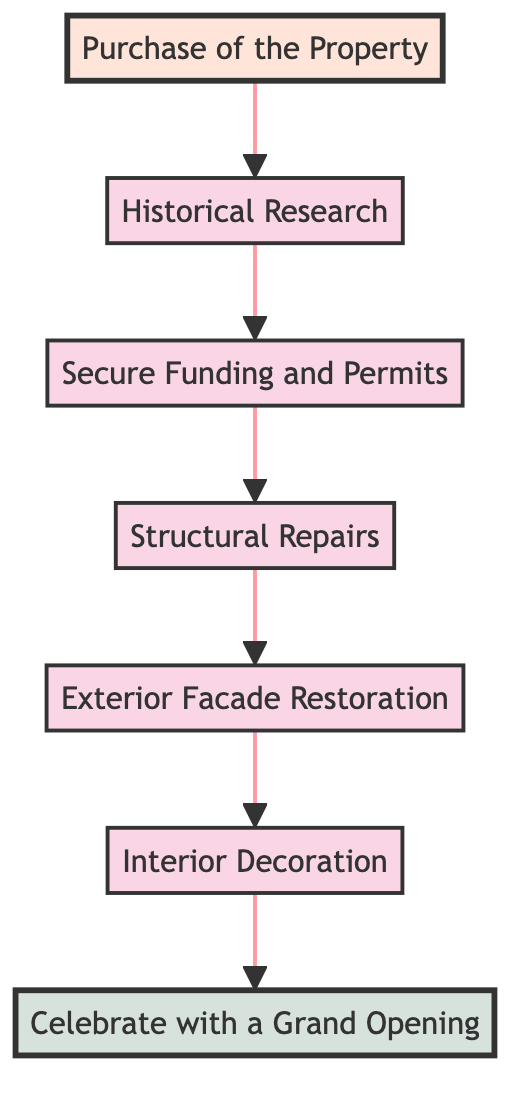What is the first step in the restoration process? The first step in the restoration process, as indicated in the diagram, is "Purchase of the Property," which is the starting point before any other steps can occur.
Answer: Purchase of the Property How many steps are there in total in the restoration process? In the diagram, there are a total of seven steps included, starting from "Purchase of the Property" and ending with "Celebrate with a Grand Opening."
Answer: 7 What comes after "Historical Research"? Following "Historical Research," the next step is "Secure Funding and Permits," which indicates the sequential process of obtaining necessary permissions and funding.
Answer: Secure Funding and Permits Which step directly precedes the "Celebrate with a Grand Opening"? Directly before "Celebrate with a Grand Opening" is "Interior Decoration," showing that the completion of the interior work leads to the grand opening event.
Answer: Interior Decoration What is the last step in the restoration process? The last step in the restoration process is "Celebrate with a Grand Opening," which signifies the culmination of all restorative efforts and the building's readiness to be showcased.
Answer: Celebrate with a Grand Opening What is the relationship between "Structural Repairs" and "Exterior Facade Restoration"? The relationship is sequential; "Structural Repairs" must be completed before moving on to "Exterior Facade Restoration," indicating that the stability of the building is prioritized before aesthetic improvements.
Answer: Sequential Which step requires obtaining permissions and grants? The step that requires obtaining permissions and grants is "Secure Funding and Permits," as this step is crucial for legally proceeding with the restoration work.
Answer: Secure Funding and Permits How many restoration tasks focus on aesthetics and design? There are three tasks that focus on aesthetics and design: "Exterior Facade Restoration," "Interior Decoration," and "Celebrate with a Grand Opening," which highlight the final appearance and celebration of the restoration.
Answer: 3 